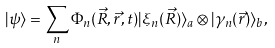Convert formula to latex. <formula><loc_0><loc_0><loc_500><loc_500>| \psi \rangle = \sum _ { n } \Phi _ { n } ( \vec { R } , \vec { r } , t ) | \xi _ { n } ( \vec { R } ) \rangle _ { a } \otimes | \gamma _ { n } ( \vec { r } ) \rangle _ { b } ,</formula> 